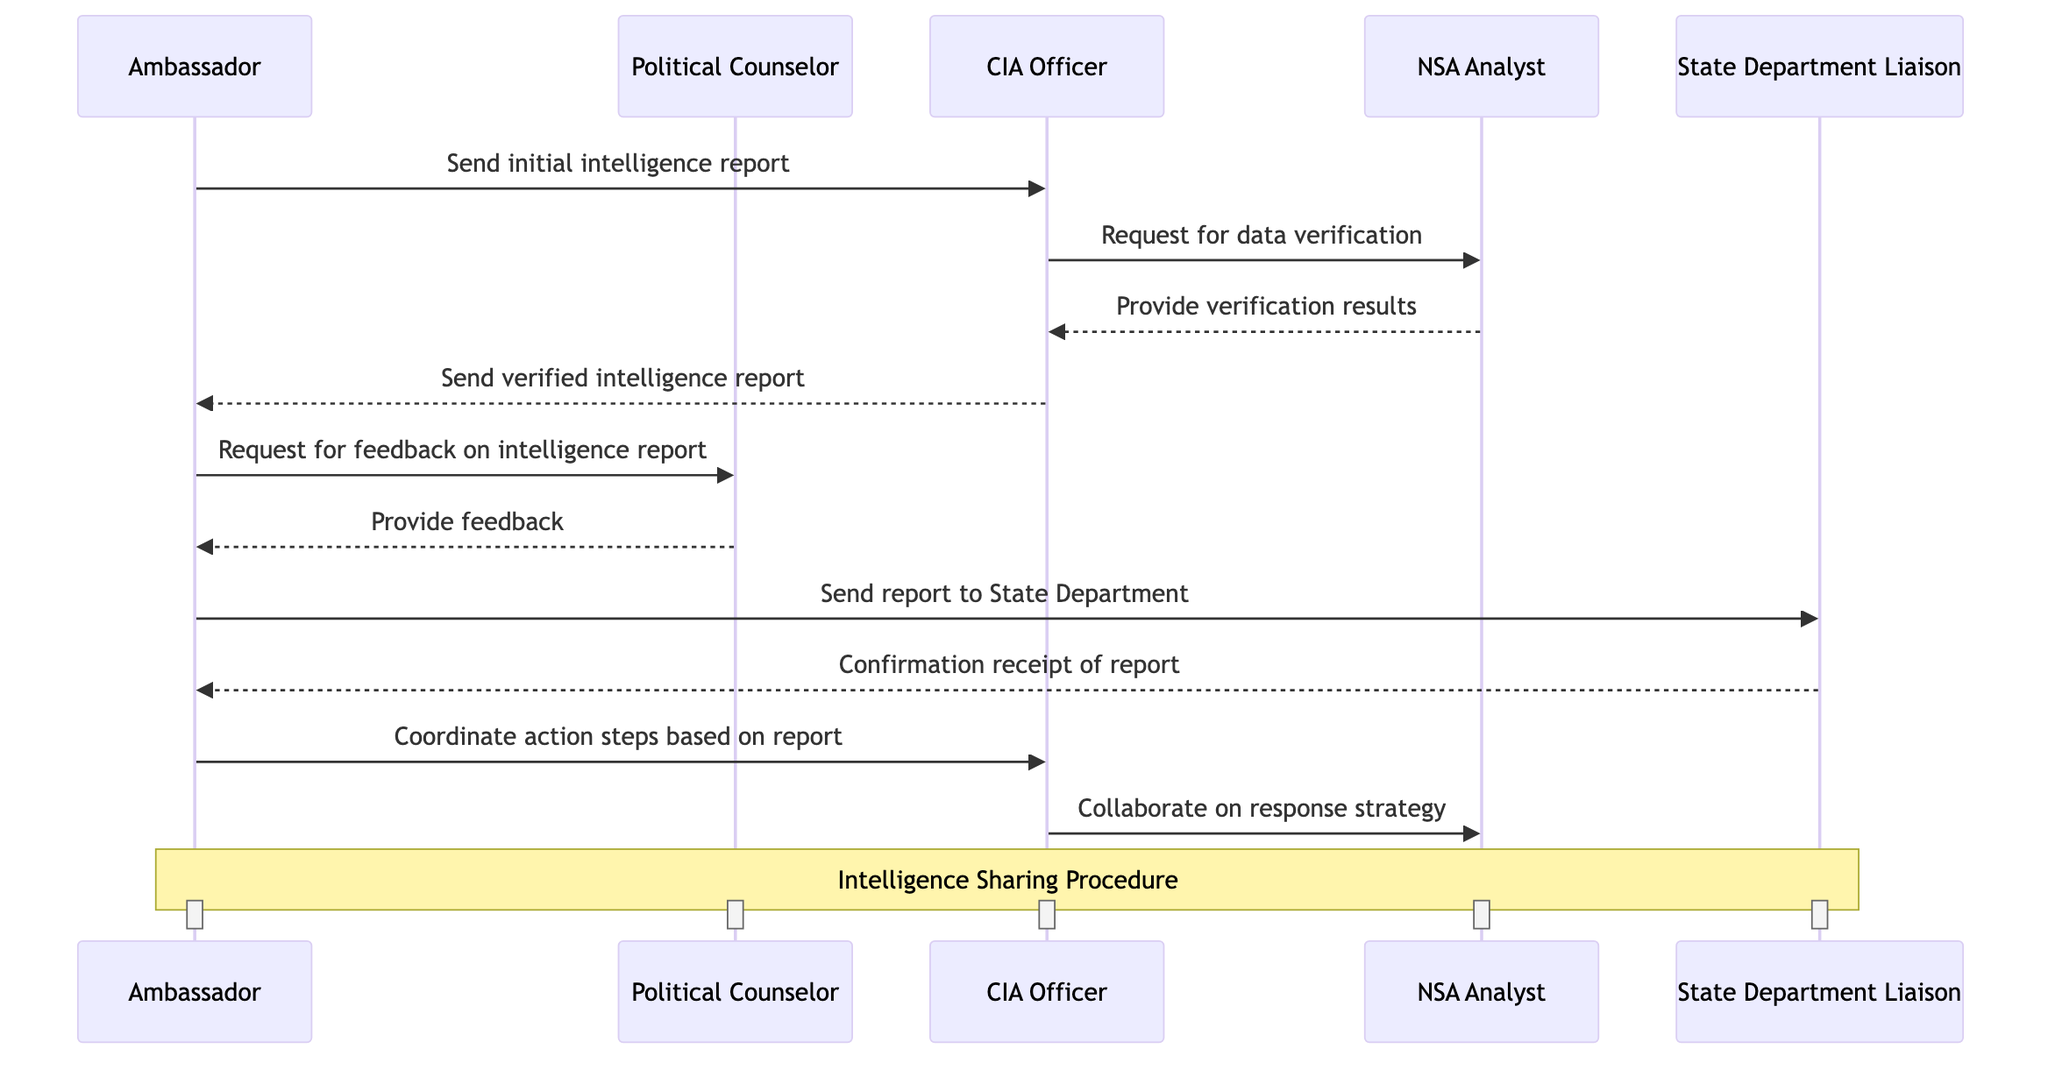What is the first action initiated by the Ambassador? The diagram shows that the Ambassador initiates the process by sending the initial intelligence report to the CIA Officer. This is the first arrow directed from the Ambassador to the CIA Officer.
Answer: Send initial intelligence report How many participants are involved in the intelligence sharing procedure? By counting the different participant names listed in the diagram, there are a total of five distinct participants: Ambassador, Political Counselor, CIA Officer, NSA Analyst, and State Department Liaison.
Answer: 5 What is the last action taken by the CIA Officer? The CIA Officer's last action in the sequence diagram is to collaborate on a response strategy with the NSA Analyst, as indicated by the final message directed from CIA Officer to NSA Analyst.
Answer: Collaborate on response strategy Who provides the verification results to the CIA Officer? Looking at the flow of communication, the NSA Analyst provides the verification results to the CIA Officer after the CIA Officer requests data verification. This is illustrated by the arrow pointing from NSA Analyst to CIA Officer.
Answer: Provide verification results Which participant confirms receipt of the report? The State Department Liaison confirms receipt of the report to the Ambassador. This can be verified by the arrow that goes from State Department Liaison back to the Ambassador marked with the confirmation message.
Answer: Confirmation receipt of report What action follows after the Ambassador requests feedback? After the Ambassador requests feedback on the intelligence report, the next action is that the Political Counselor provides feedback back to the Ambassador, resulting in a back-and-forth interaction between these two participants.
Answer: Provide feedback What role does the NSA Analyst play in this diagram? The NSA Analyst receives a request for data verification from the CIA Officer, provides verification results, and collaborates on a response strategy, indicating that their role involves verification and response strategy development.
Answer: Verification and response strategy What type of communication is primarily represented in this diagram? The diagram primarily represents a structured communication exchange that details the process of intelligence sharing, illustrating the direct messages and confirmations between participants in the embassy and intelligence agencies.
Answer: Intelligence sharing procedure 